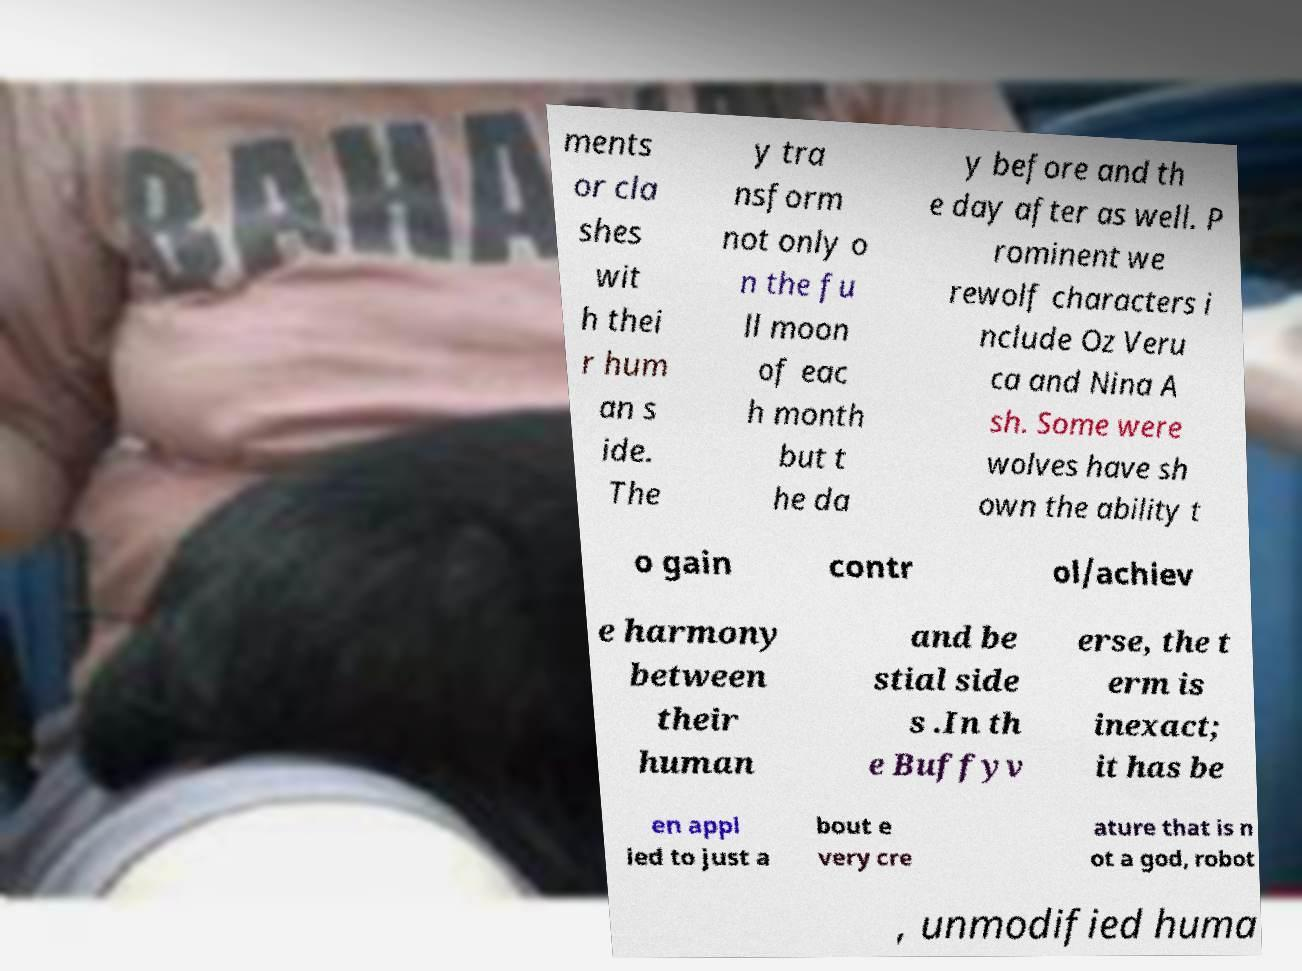Can you read and provide the text displayed in the image?This photo seems to have some interesting text. Can you extract and type it out for me? ments or cla shes wit h thei r hum an s ide. The y tra nsform not only o n the fu ll moon of eac h month but t he da y before and th e day after as well. P rominent we rewolf characters i nclude Oz Veru ca and Nina A sh. Some were wolves have sh own the ability t o gain contr ol/achiev e harmony between their human and be stial side s .In th e Buffyv erse, the t erm is inexact; it has be en appl ied to just a bout e very cre ature that is n ot a god, robot , unmodified huma 